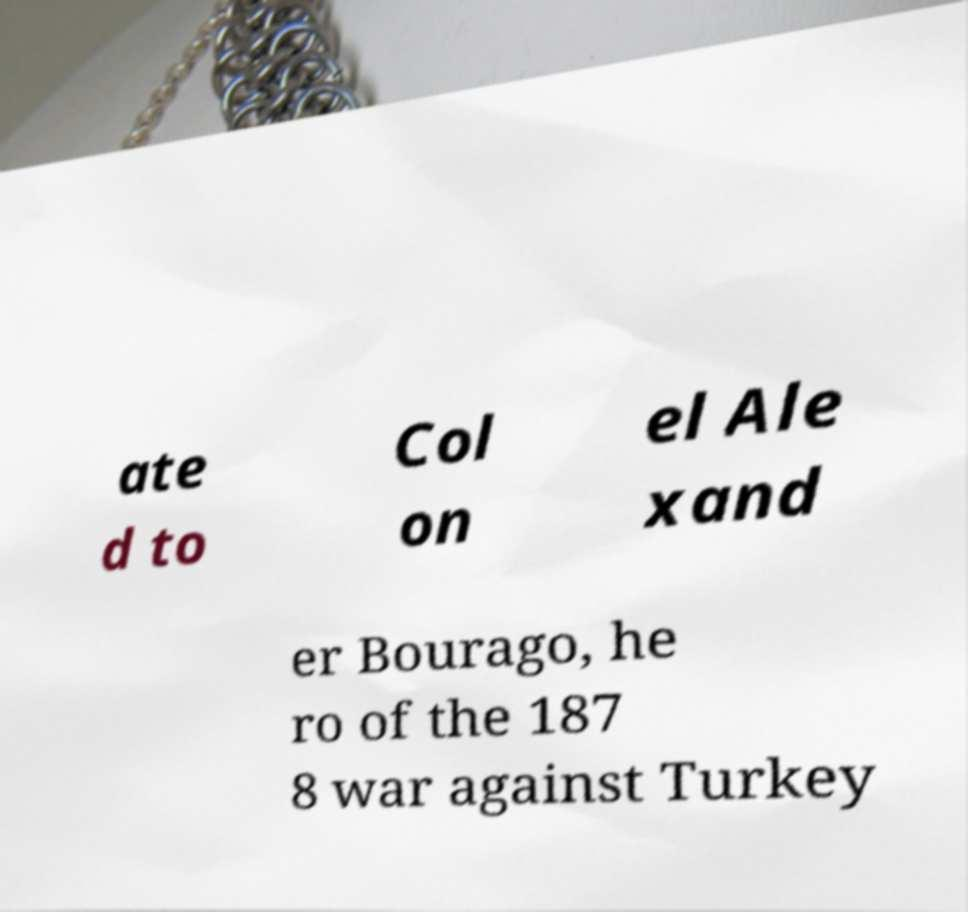Can you read and provide the text displayed in the image?This photo seems to have some interesting text. Can you extract and type it out for me? ate d to Col on el Ale xand er Bourago, he ro of the 187 8 war against Turkey 